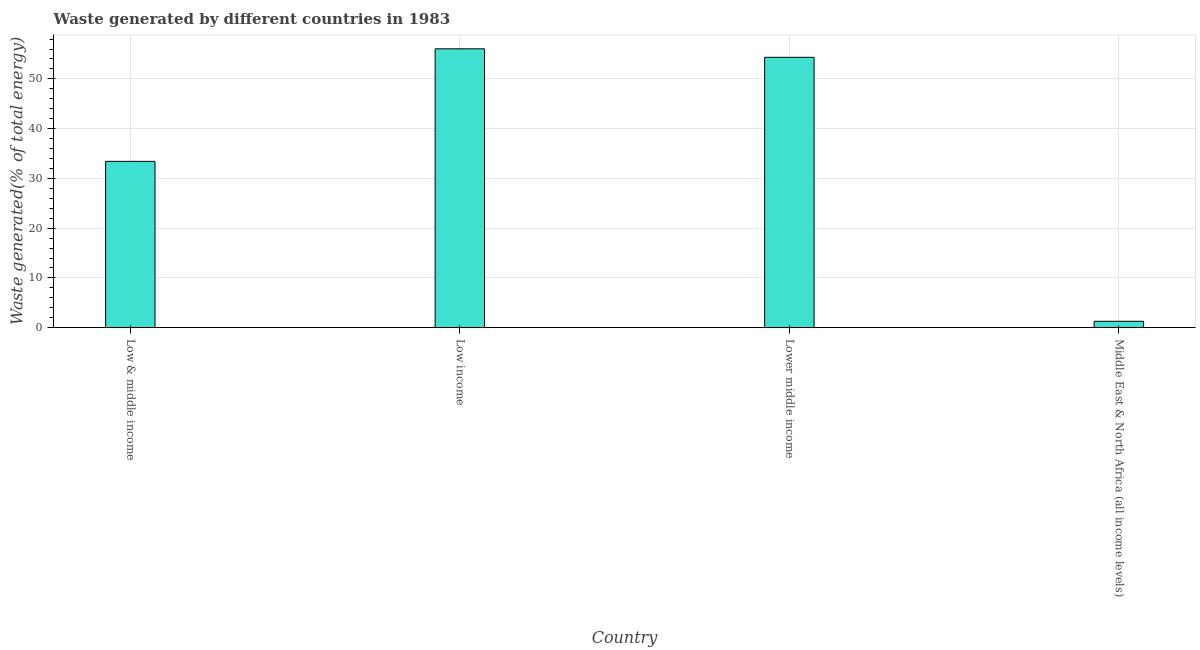What is the title of the graph?
Ensure brevity in your answer.  Waste generated by different countries in 1983. What is the label or title of the X-axis?
Provide a short and direct response. Country. What is the label or title of the Y-axis?
Make the answer very short. Waste generated(% of total energy). What is the amount of waste generated in Middle East & North Africa (all income levels)?
Your response must be concise. 1.28. Across all countries, what is the maximum amount of waste generated?
Your response must be concise. 56.04. Across all countries, what is the minimum amount of waste generated?
Give a very brief answer. 1.28. In which country was the amount of waste generated minimum?
Your response must be concise. Middle East & North Africa (all income levels). What is the sum of the amount of waste generated?
Offer a terse response. 145.07. What is the difference between the amount of waste generated in Low & middle income and Lower middle income?
Make the answer very short. -20.91. What is the average amount of waste generated per country?
Provide a short and direct response. 36.27. What is the median amount of waste generated?
Your response must be concise. 43.88. What is the ratio of the amount of waste generated in Low income to that in Middle East & North Africa (all income levels)?
Provide a short and direct response. 43.76. Is the amount of waste generated in Low income less than that in Middle East & North Africa (all income levels)?
Offer a very short reply. No. Is the difference between the amount of waste generated in Lower middle income and Middle East & North Africa (all income levels) greater than the difference between any two countries?
Offer a terse response. No. What is the difference between the highest and the second highest amount of waste generated?
Offer a very short reply. 1.71. Is the sum of the amount of waste generated in Lower middle income and Middle East & North Africa (all income levels) greater than the maximum amount of waste generated across all countries?
Keep it short and to the point. No. What is the difference between the highest and the lowest amount of waste generated?
Your answer should be very brief. 54.76. In how many countries, is the amount of waste generated greater than the average amount of waste generated taken over all countries?
Ensure brevity in your answer.  2. How many bars are there?
Give a very brief answer. 4. Are all the bars in the graph horizontal?
Ensure brevity in your answer.  No. What is the difference between two consecutive major ticks on the Y-axis?
Keep it short and to the point. 10. What is the Waste generated(% of total energy) in Low & middle income?
Keep it short and to the point. 33.42. What is the Waste generated(% of total energy) of Low income?
Provide a short and direct response. 56.04. What is the Waste generated(% of total energy) in Lower middle income?
Your response must be concise. 54.33. What is the Waste generated(% of total energy) in Middle East & North Africa (all income levels)?
Your response must be concise. 1.28. What is the difference between the Waste generated(% of total energy) in Low & middle income and Low income?
Provide a succinct answer. -22.62. What is the difference between the Waste generated(% of total energy) in Low & middle income and Lower middle income?
Offer a terse response. -20.91. What is the difference between the Waste generated(% of total energy) in Low & middle income and Middle East & North Africa (all income levels)?
Provide a short and direct response. 32.14. What is the difference between the Waste generated(% of total energy) in Low income and Lower middle income?
Provide a short and direct response. 1.71. What is the difference between the Waste generated(% of total energy) in Low income and Middle East & North Africa (all income levels)?
Your response must be concise. 54.76. What is the difference between the Waste generated(% of total energy) in Lower middle income and Middle East & North Africa (all income levels)?
Your answer should be very brief. 53.05. What is the ratio of the Waste generated(% of total energy) in Low & middle income to that in Low income?
Provide a short and direct response. 0.6. What is the ratio of the Waste generated(% of total energy) in Low & middle income to that in Lower middle income?
Offer a terse response. 0.61. What is the ratio of the Waste generated(% of total energy) in Low & middle income to that in Middle East & North Africa (all income levels)?
Ensure brevity in your answer.  26.1. What is the ratio of the Waste generated(% of total energy) in Low income to that in Lower middle income?
Your answer should be very brief. 1.03. What is the ratio of the Waste generated(% of total energy) in Low income to that in Middle East & North Africa (all income levels)?
Provide a short and direct response. 43.76. What is the ratio of the Waste generated(% of total energy) in Lower middle income to that in Middle East & North Africa (all income levels)?
Keep it short and to the point. 42.42. 